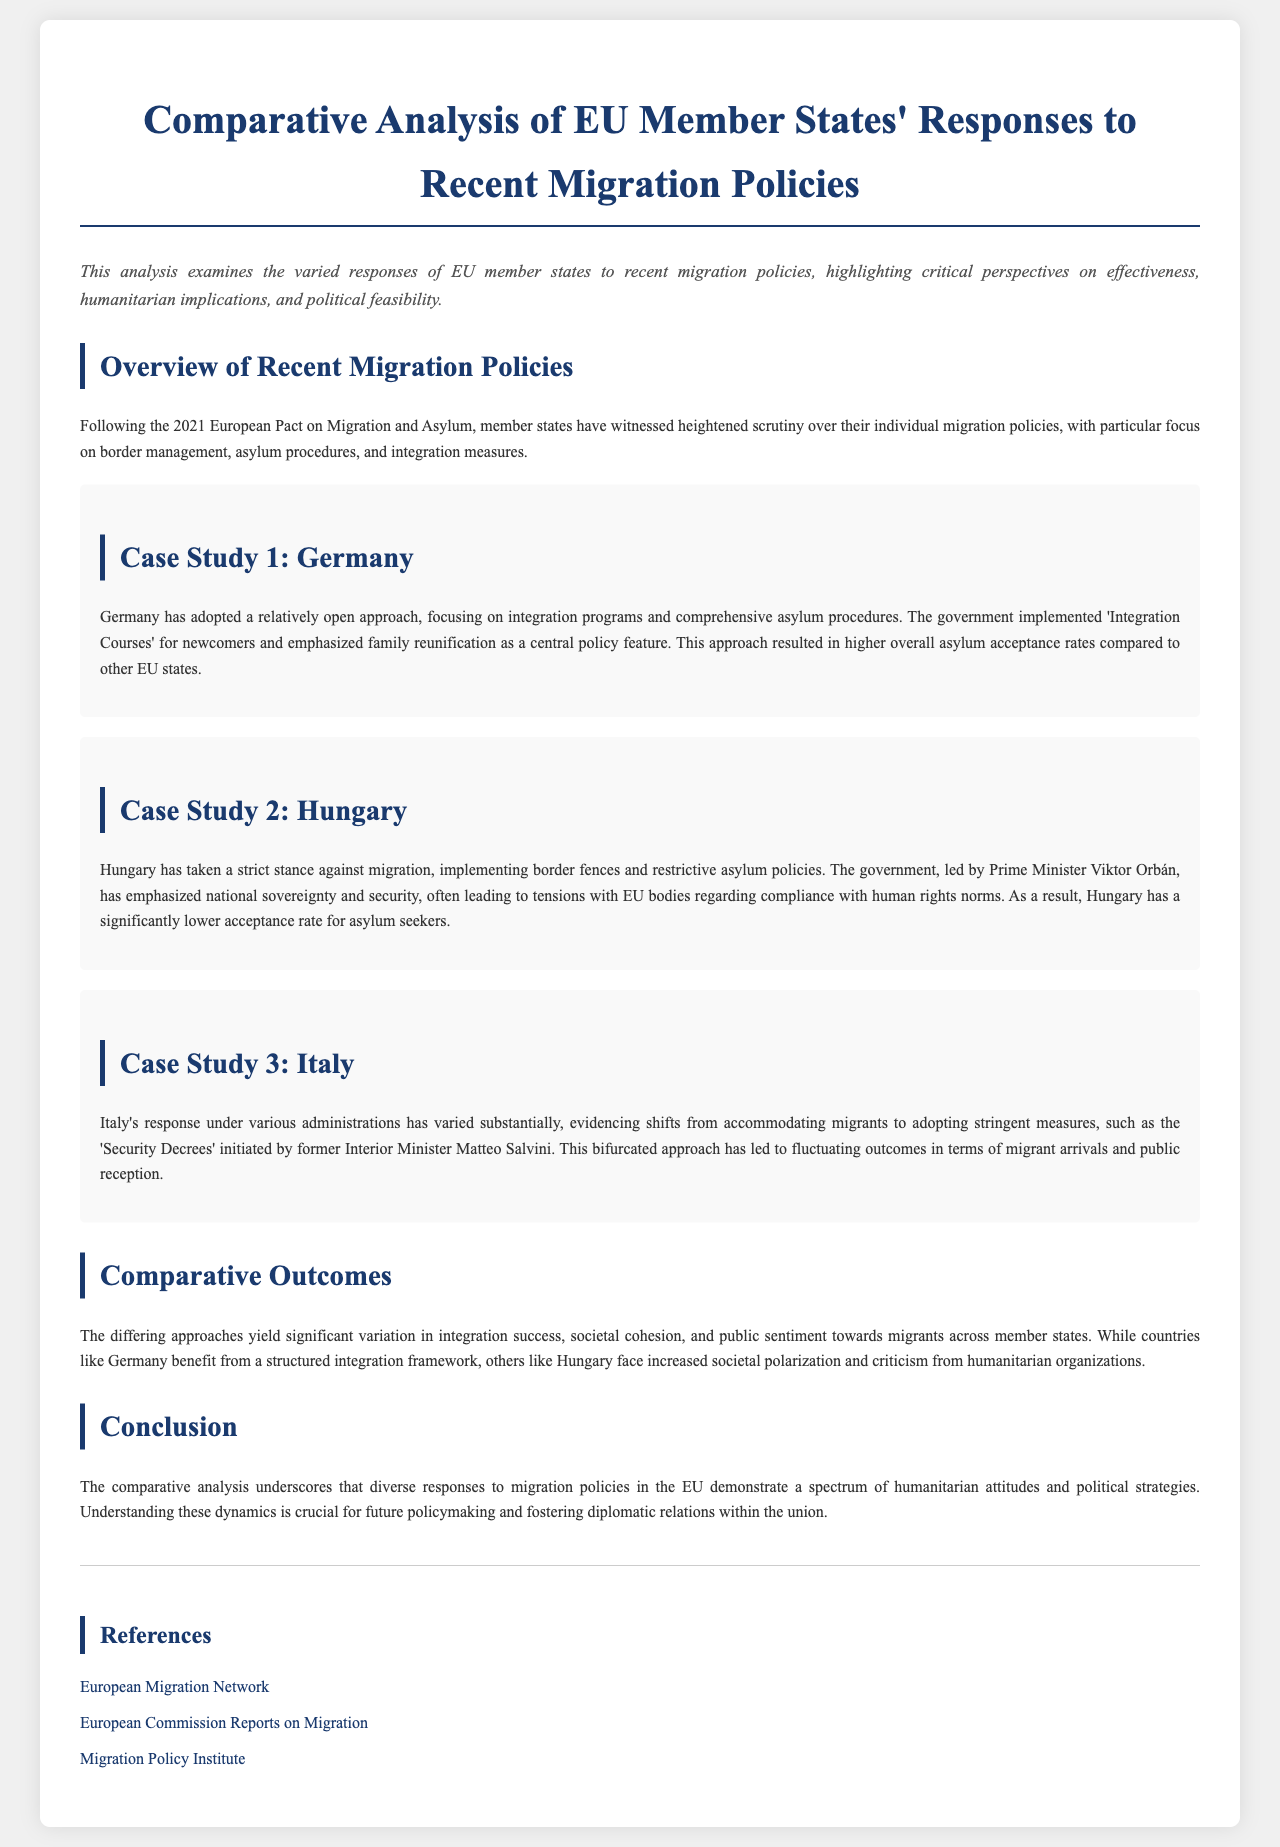What is the title of the document? The title is prominently displayed at the top of the document, summarizing its content.
Answer: Comparative Analysis of EU Member States' Responses to Recent Migration Policies What country is highlighted for its open approach to migration? The document provides case studies of specific countries, noting Germany's strategy.
Answer: Germany Which country's government emphasizes national sovereignty and security? The document describes Hungary's stance and the leadership style of its government.
Answer: Hungary What initiative did Germany implement for newcomers? The document specifically mentions programs designed to aid integration for migrants.
Answer: Integration Courses What event triggered scrutiny over member states' migration policies? The document references a significant policy decision that impacted EU states’ approaches to migration.
Answer: 2021 European Pact on Migration and Asylum What describes Hungary's acceptance rate for asylum seekers? The document notes Hungary's performance in terms of asylum acceptance in comparison to others.
Answer: Significantly lower Which two countries had fluctuating migration outcomes? The analysis focuses on contrasting the responses of specific nations concerning migration policies.
Answer: Italy and Hungary What aspect of migration does the document highlight as crucial for policymaking? The conclusion emphasizes the importance of understanding specific dynamics for future strategies.
Answer: Humanitarian attitudes What kind of overview does the document provide at the beginning? The first section establishes a context for the analysis by summarizing recent policies.
Answer: Overview of Recent Migration Policies 